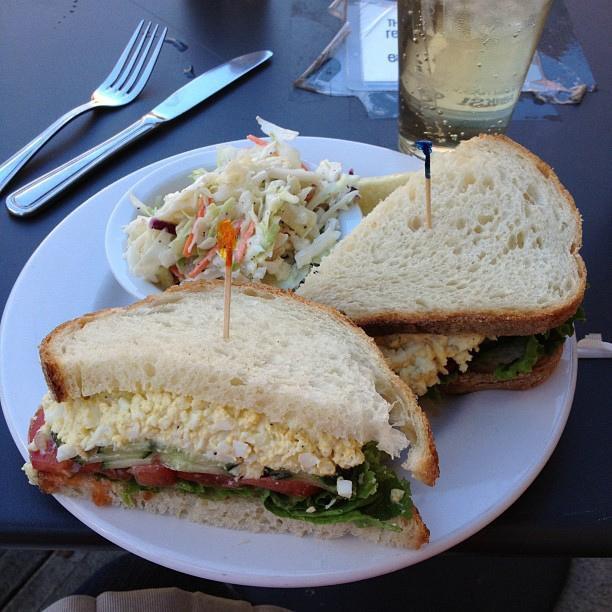How many utensils are there?
Give a very brief answer. 2. How many sandwiches are visible?
Give a very brief answer. 2. How many forks can be seen?
Give a very brief answer. 1. 